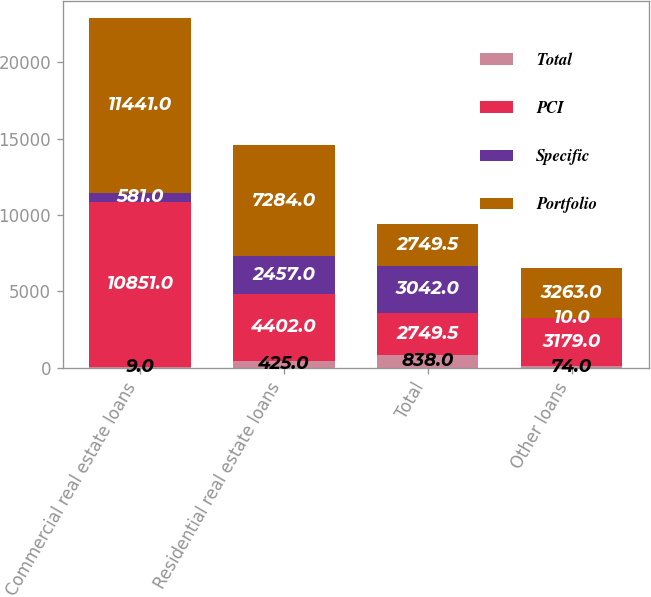Convert chart to OTSL. <chart><loc_0><loc_0><loc_500><loc_500><stacked_bar_chart><ecel><fcel>Commercial real estate loans<fcel>Residential real estate loans<fcel>Total<fcel>Other loans<nl><fcel>Total<fcel>9<fcel>425<fcel>838<fcel>74<nl><fcel>PCI<fcel>10851<fcel>4402<fcel>2749.5<fcel>3179<nl><fcel>Specific<fcel>581<fcel>2457<fcel>3042<fcel>10<nl><fcel>Portfolio<fcel>11441<fcel>7284<fcel>2749.5<fcel>3263<nl></chart> 